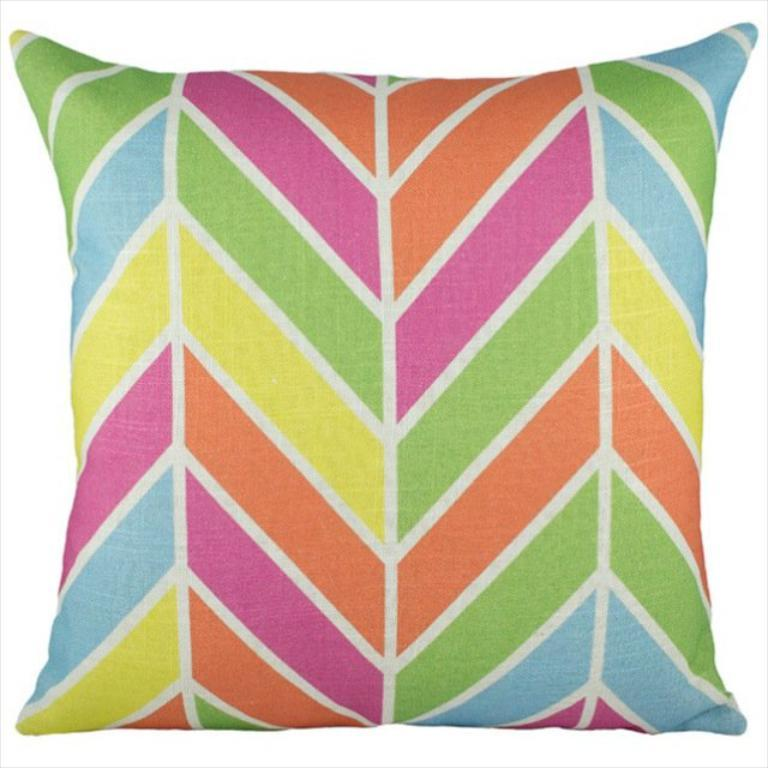What object can be seen in the image? There is a pillow in the image. What might the pillow be used for? The pillow could be used for support or comfort while sitting or lying down. What material is the pillow likely made of? The pillow could be made of various materials, such as cotton, foam, or feathers. What type of sleet can be seen falling on the pillow in the image? There is no sleet present in the image; it only features a pillow. What type of insurance policy is associated with the pillow in the image? There is no insurance policy associated with the pillow in the image, as it is an inanimate object. 